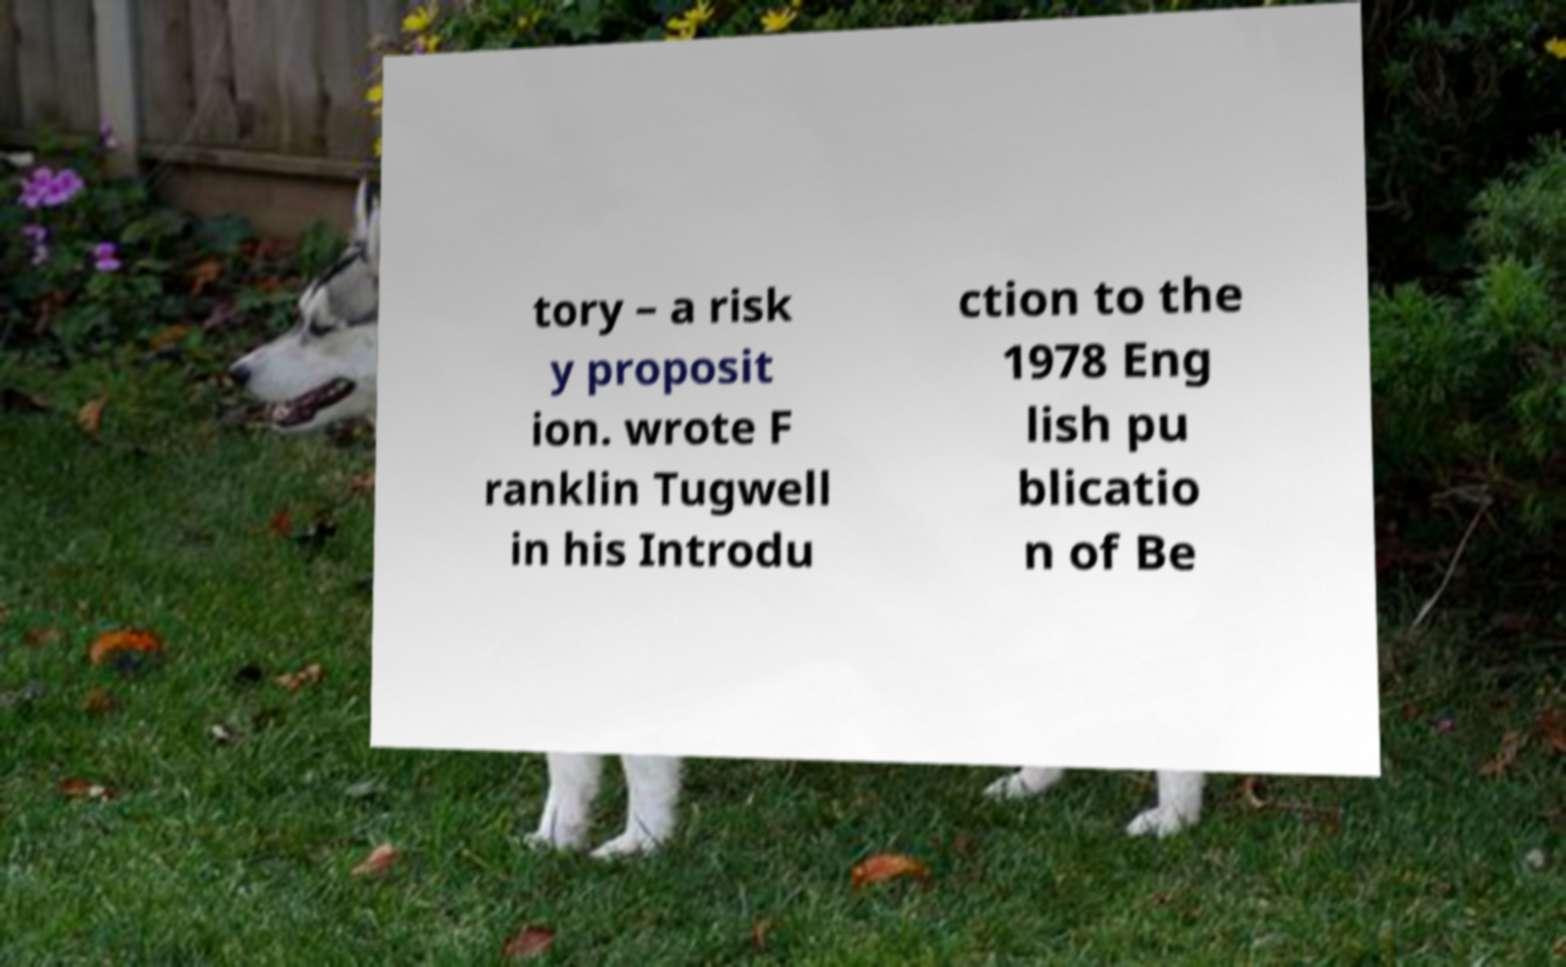Could you extract and type out the text from this image? tory – a risk y proposit ion. wrote F ranklin Tugwell in his Introdu ction to the 1978 Eng lish pu blicatio n of Be 